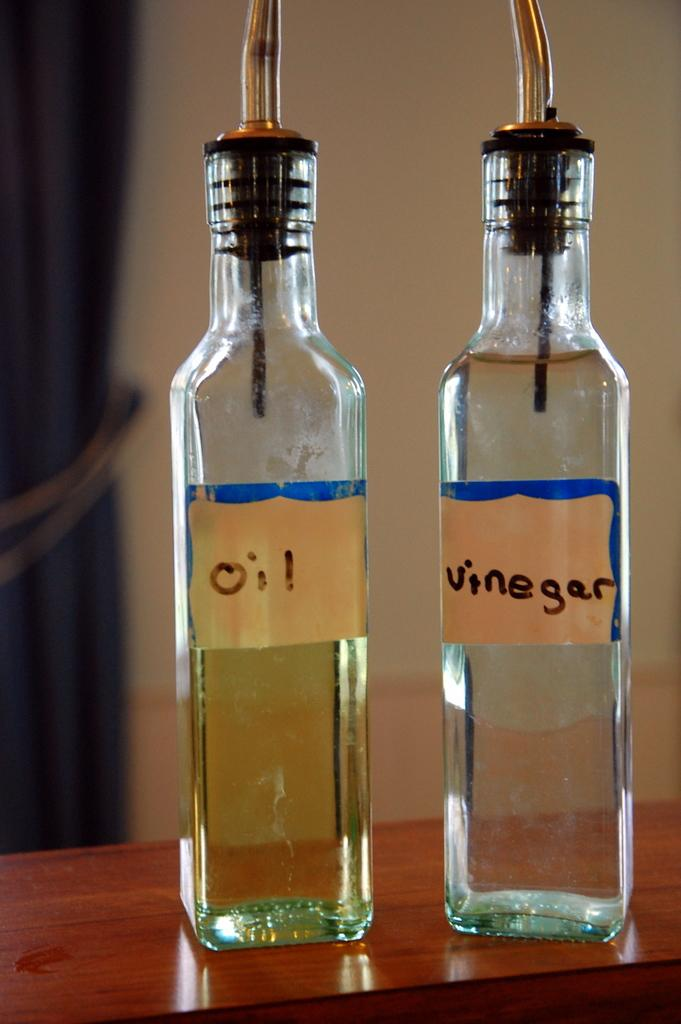<image>
Summarize the visual content of the image. Oil and Vinegar bottles that are standing on a shelf. 